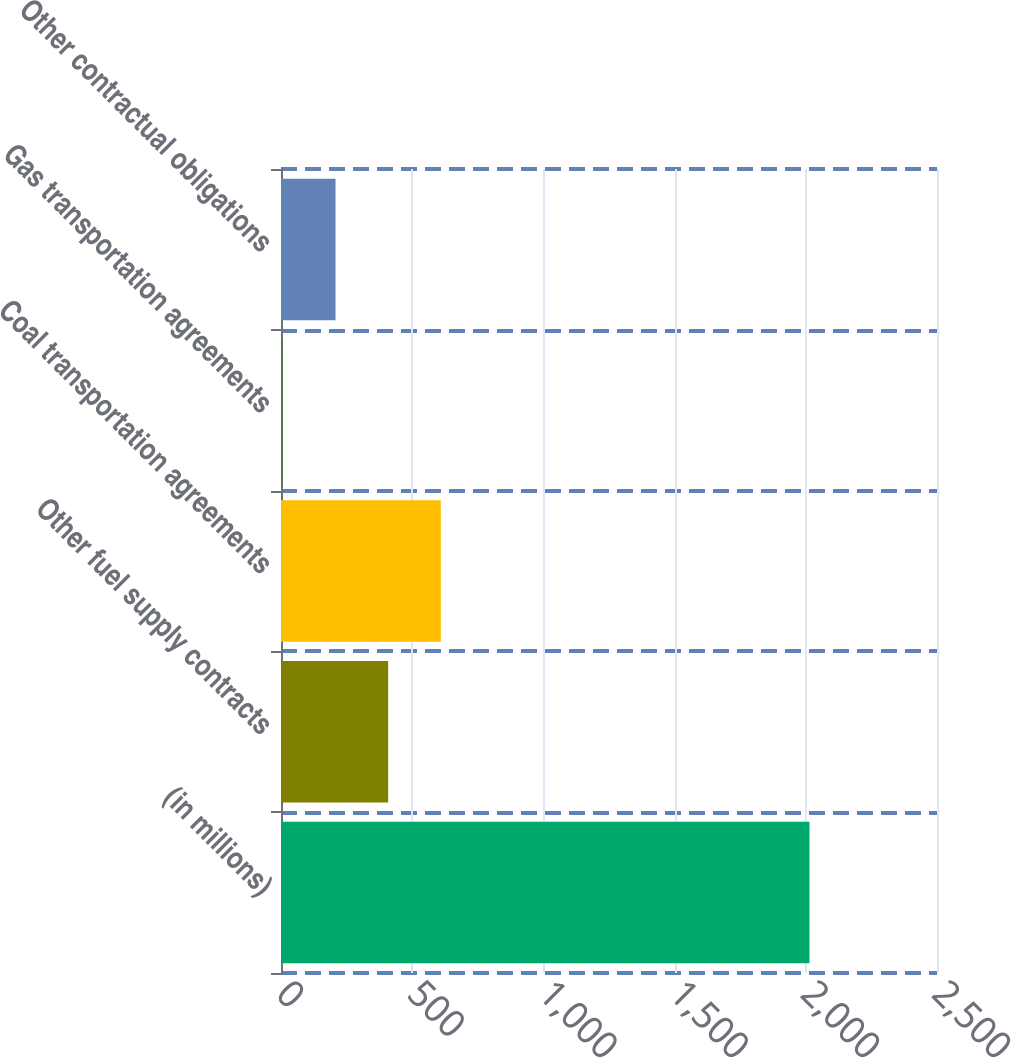<chart> <loc_0><loc_0><loc_500><loc_500><bar_chart><fcel>(in millions)<fcel>Other fuel supply contracts<fcel>Coal transportation agreements<fcel>Gas transportation agreements<fcel>Other contractual obligations<nl><fcel>2014<fcel>408.4<fcel>609.1<fcel>7<fcel>207.7<nl></chart> 